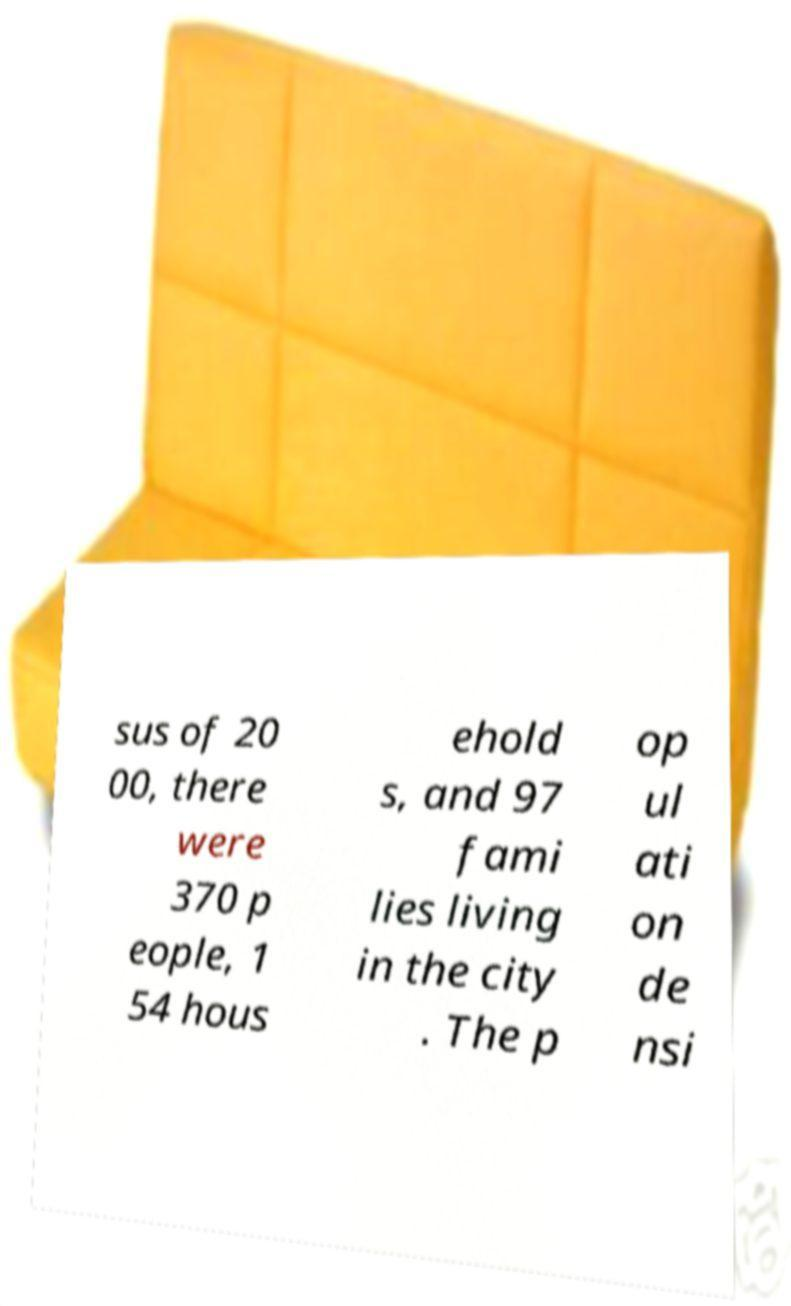Could you extract and type out the text from this image? sus of 20 00, there were 370 p eople, 1 54 hous ehold s, and 97 fami lies living in the city . The p op ul ati on de nsi 